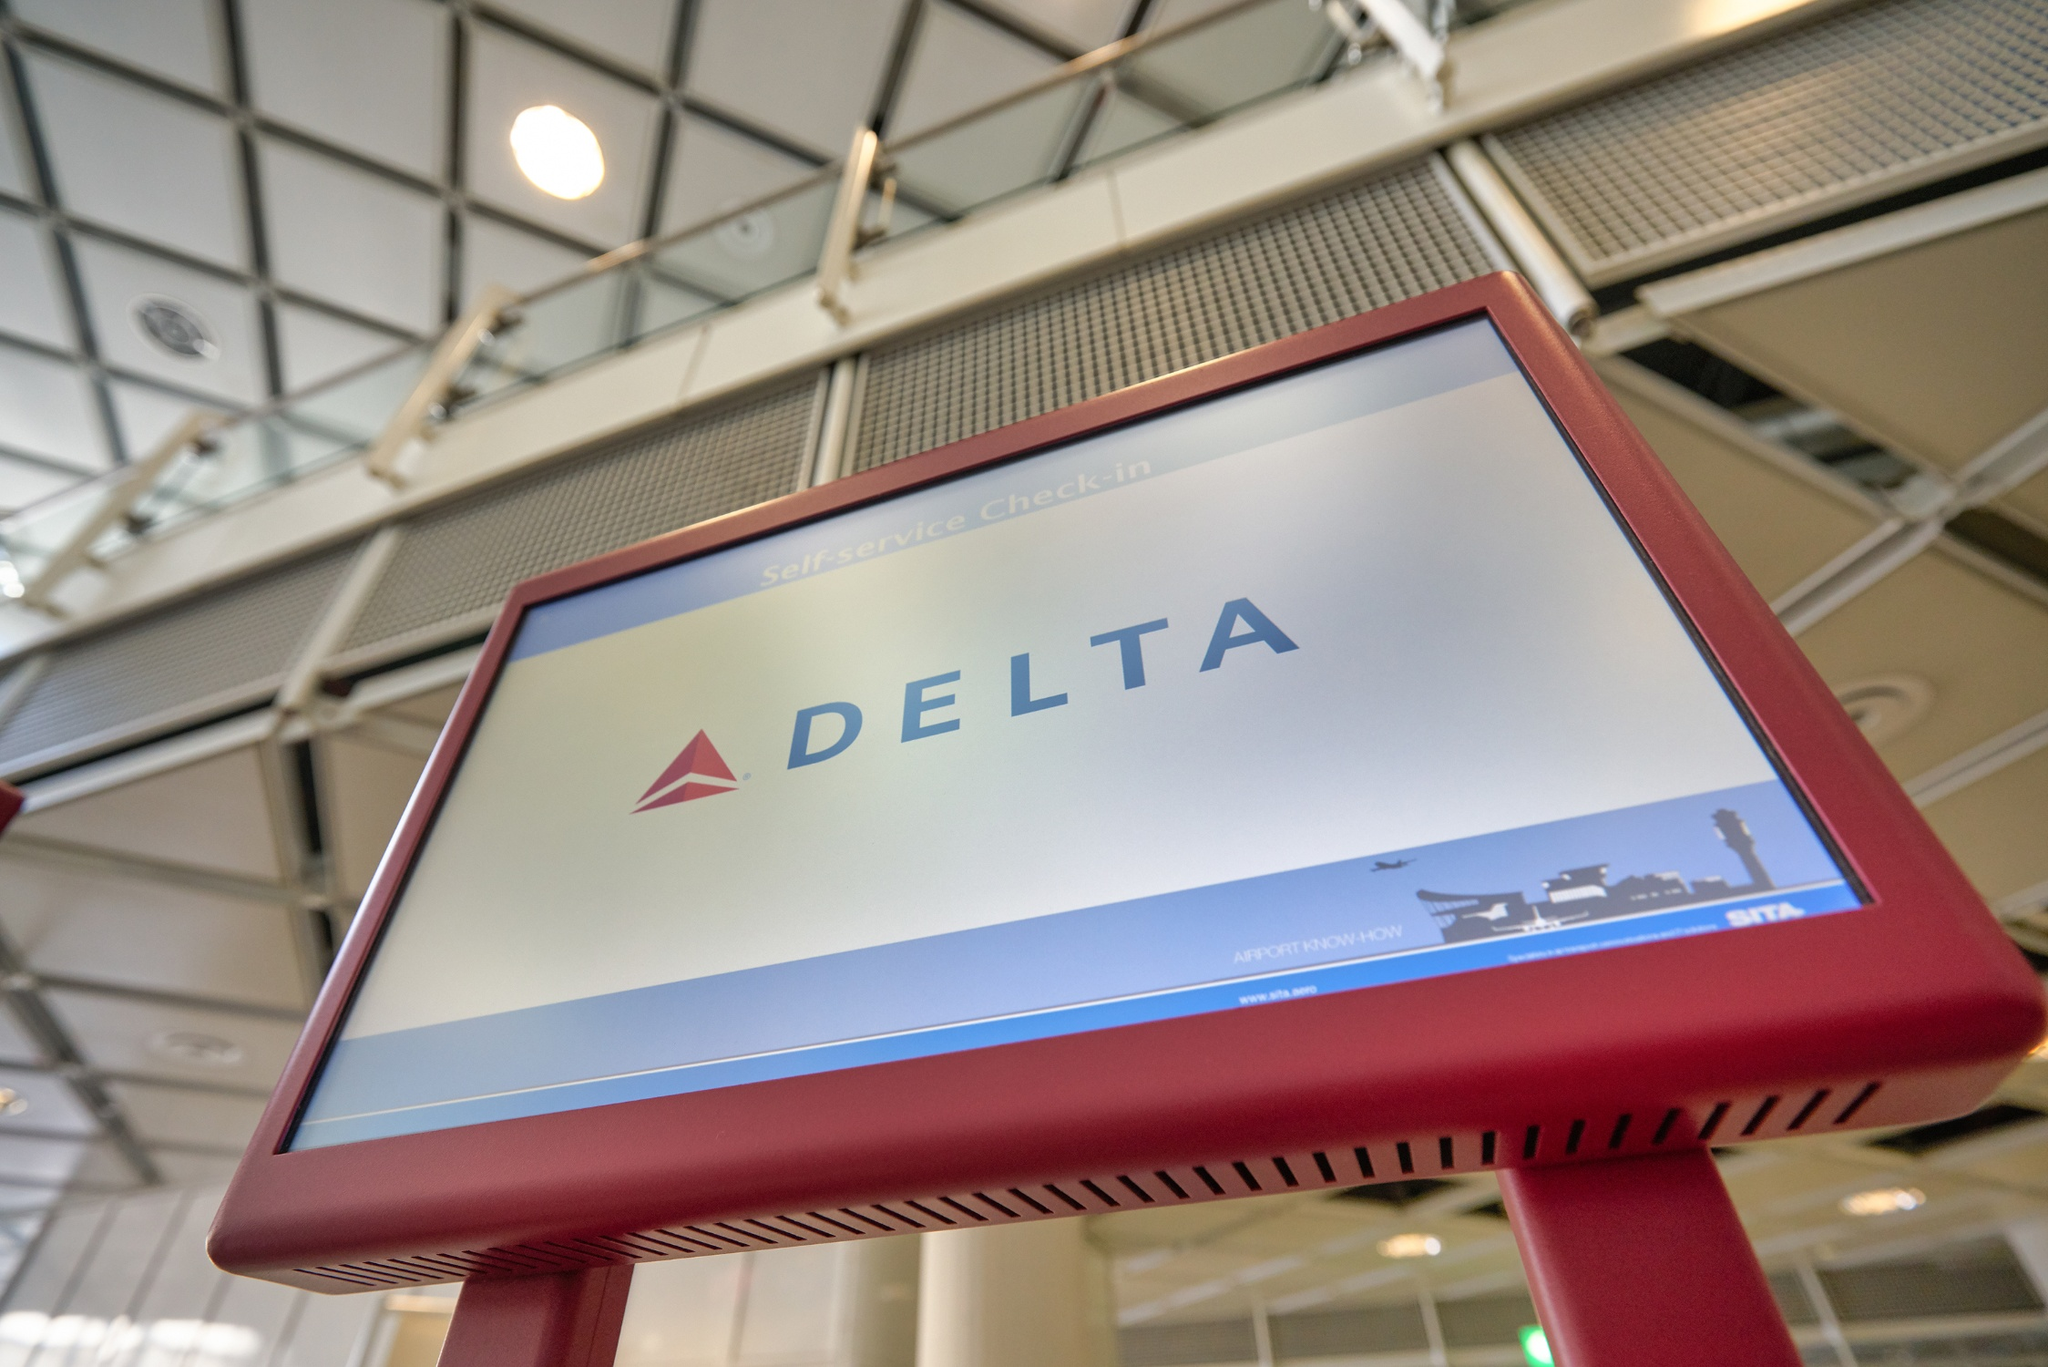What do you see happening in this image? The image shows a striking red Delta Airlines self-service check-in kiosk situated within an airport terminal. Prominently featured on the kiosk's large screen is the Delta logo accompanied by the words 'Self-service Check-in', indicating that passengers can utilize this kiosk for a smooth and quick check-in process. The image is taken from a low angle, emphasizing the height and prominence of the kiosk. Surrounding it, the bright terminal environment can be seen, characterized by a spacious design, high ceilings, and large windows, which allow plenty of natural light to illuminate the area. 